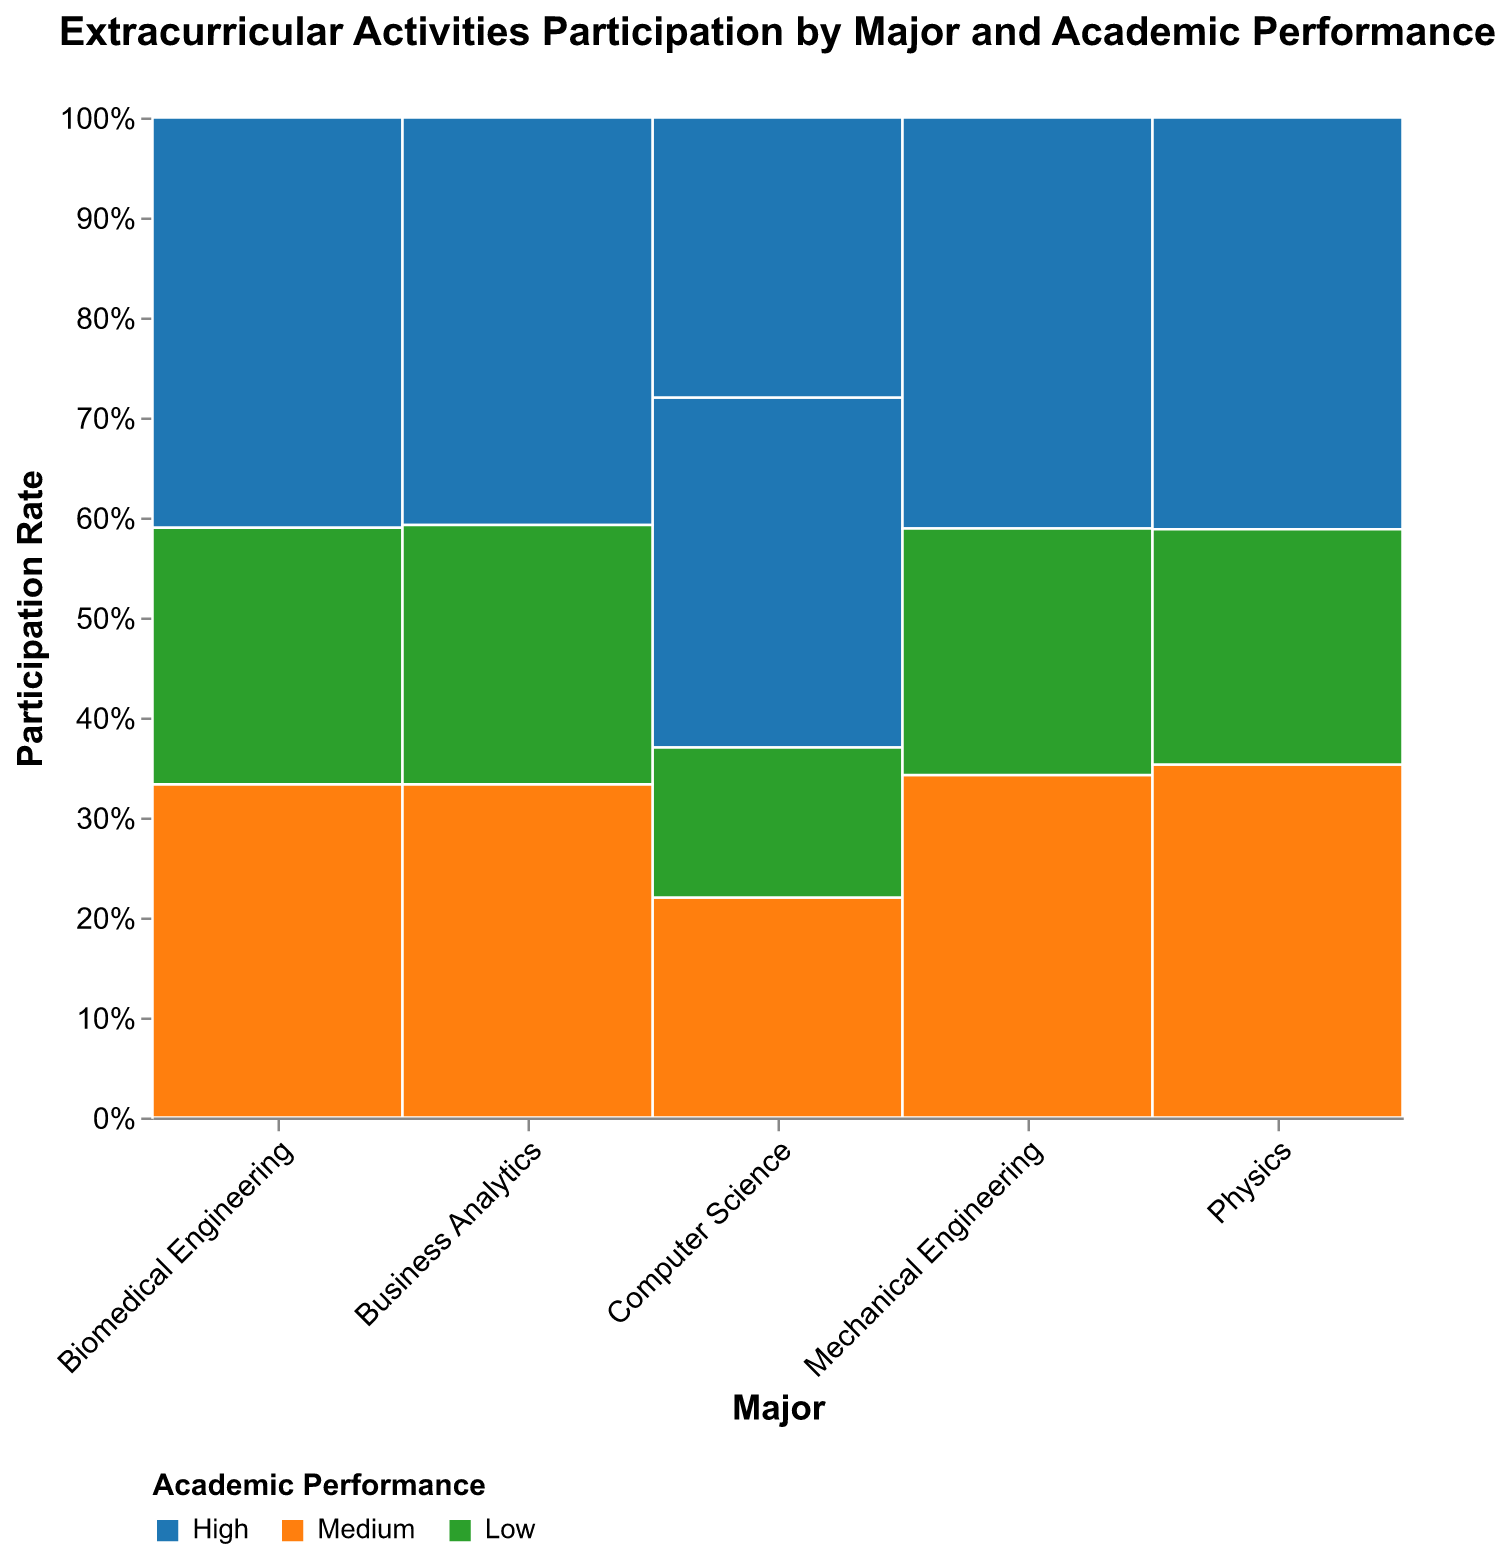What is the title of the figure? The title of the figure is written at the top of the plot. It reads "Extracurricular Activities Participation by Major and Academic Performance".
Answer: Extracurricular Activities Participation by Major and Academic Performance What are the three levels of Academic Performance shown in the plot? The levels of Academic Performance are represented by different colors in the plot: blue for High, orange for Medium, and green for Low.
Answer: High, Medium, Low Which major has the highest participation rate in extracurricular activities with high academic performance? To answer this, we look at the segments for high academic performance in each major and compare their sizes. Computer Science has the highest participation rate among the listed categories.
Answer: Computer Science In which major do students with low academic performance participate least in extracurricular activities? We compare the segments corresponding to low academic performance for each major and find that Computer Science students have the lowest participation rate in this category.
Answer: Computer Science What's the sum of participation rates for Biomedical Engineering students across all academic performance levels? We sum the participation rates of Biomedical Engineering students for High (32), Medium (26), and Low (20). The sum is 32 + 26 + 20 = 78.
Answer: 78 What is the average participation rate of Mechanical Engineering students with medium academic performance? We have one value for Mechanical Engineering students with medium academic performance: 25. Since there's only one value, the average is 25.
Answer: 25 Which major has the most balanced participation across different academic performance levels? The major with the most evenly distributed segment sizes across High, Medium, and Low performance levels will be the most balanced. Biomedical Engineering has relatively balanced segments compared to others.
Answer: Biomedical Engineering In which major does the medium academic performance contribute the highest proportion of the total participation rate? We compare the medium academic performance segment's size relative to other performance levels in each major. Mechanical Engineering's medium academic performance segment is quite large compared to others.
Answer: Mechanical Engineering 